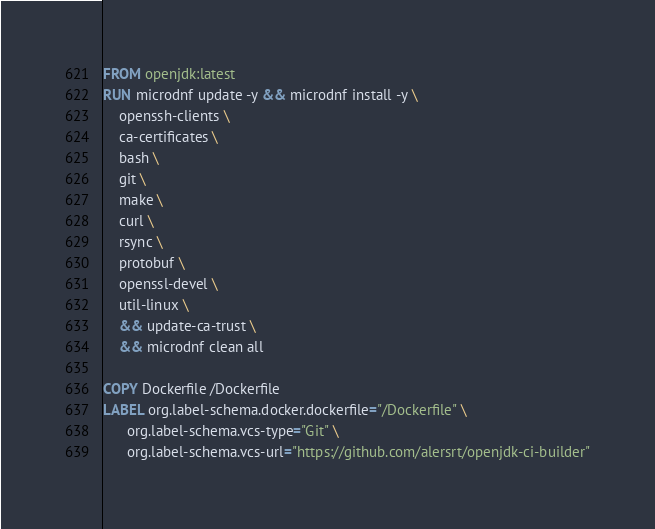Convert code to text. <code><loc_0><loc_0><loc_500><loc_500><_Dockerfile_>FROM openjdk:latest
RUN microdnf update -y && microdnf install -y \ 
    openssh-clients \
    ca-certificates \ 
    bash \
    git \
    make \
    curl \ 
    rsync \ 
    protobuf \
    openssl-devel \
    util-linux \
    && update-ca-trust \
    && microdnf clean all

COPY Dockerfile /Dockerfile
LABEL org.label-schema.docker.dockerfile="/Dockerfile" \
      org.label-schema.vcs-type="Git" \
      org.label-schema.vcs-url="https://github.com/alersrt/openjdk-ci-builder"
</code> 